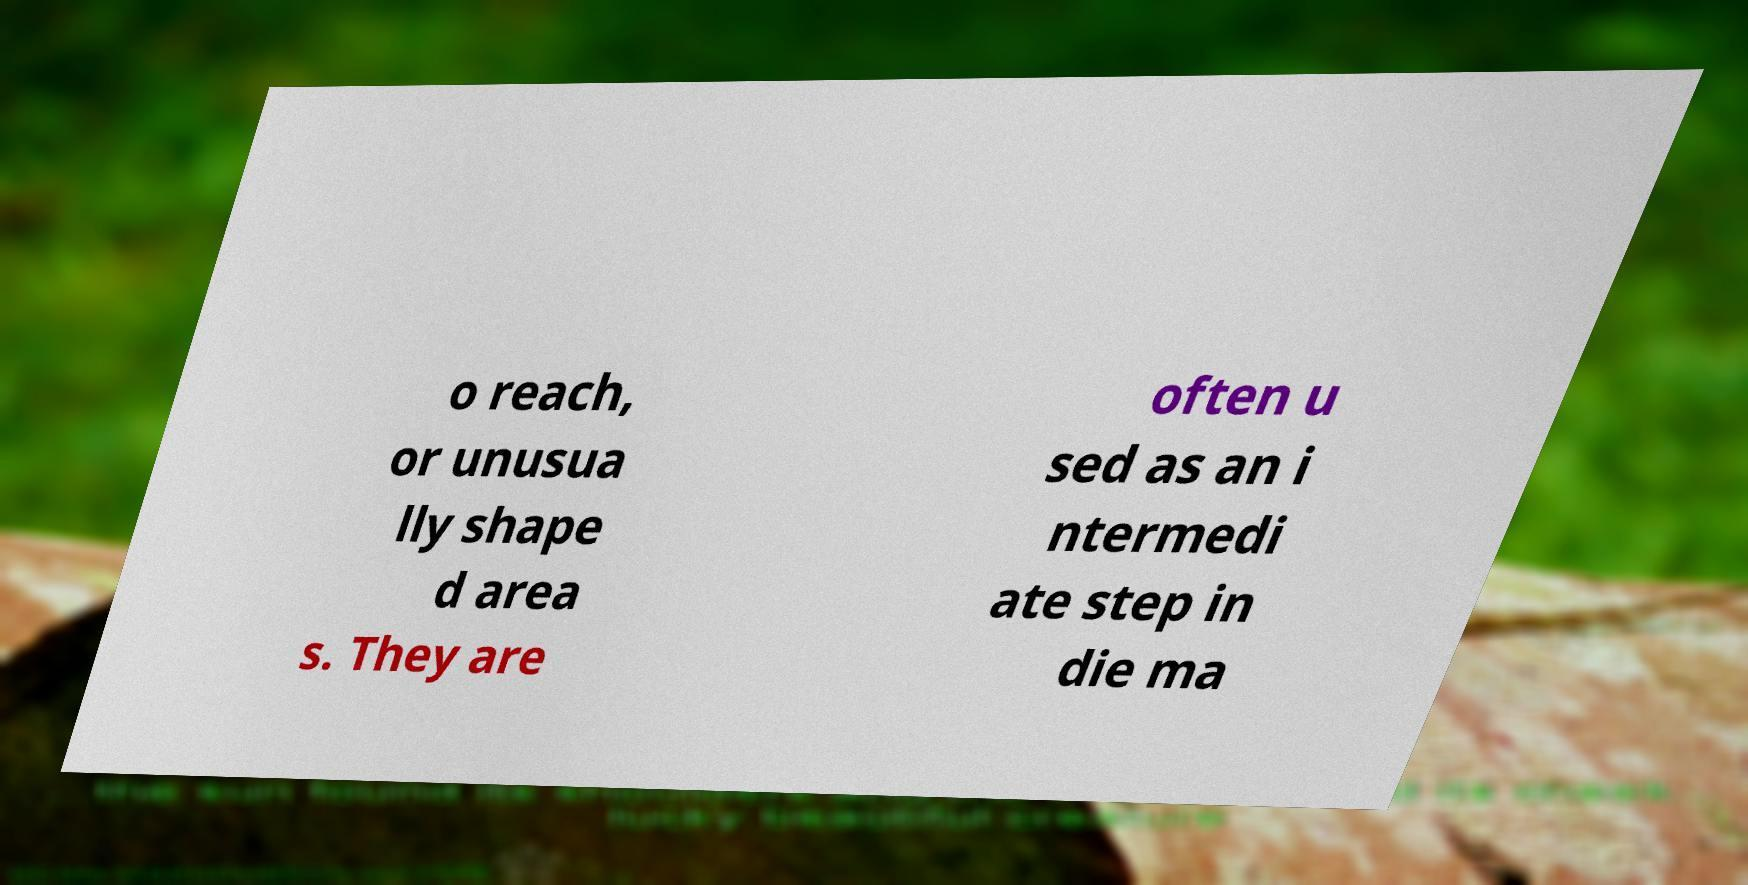Could you assist in decoding the text presented in this image and type it out clearly? o reach, or unusua lly shape d area s. They are often u sed as an i ntermedi ate step in die ma 